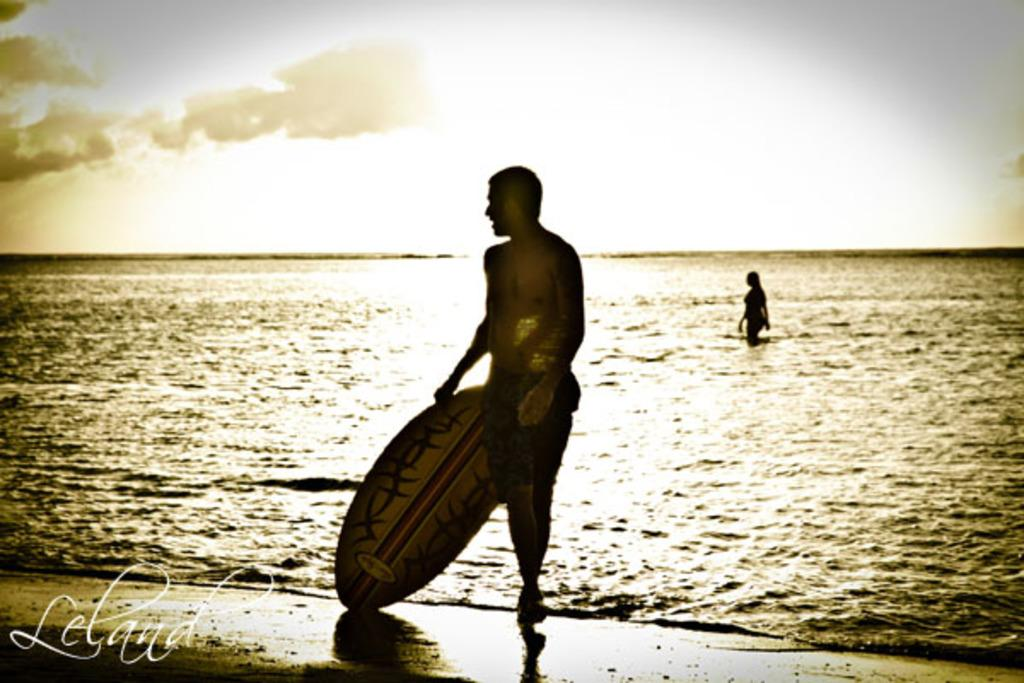What can be seen in the background of the image? The background of the image includes sky with clouds. What is the main setting of the image? The image depicts a sea. How many people are in the image? There is a woman and a man in the image. What is the man doing in the image? The man is standing and holding a surfboard in his hand. How many boys are present in the crowd in the image? There is no crowd or boys present in the image. The image features a woman, a man, and a surfboard near a sea. 